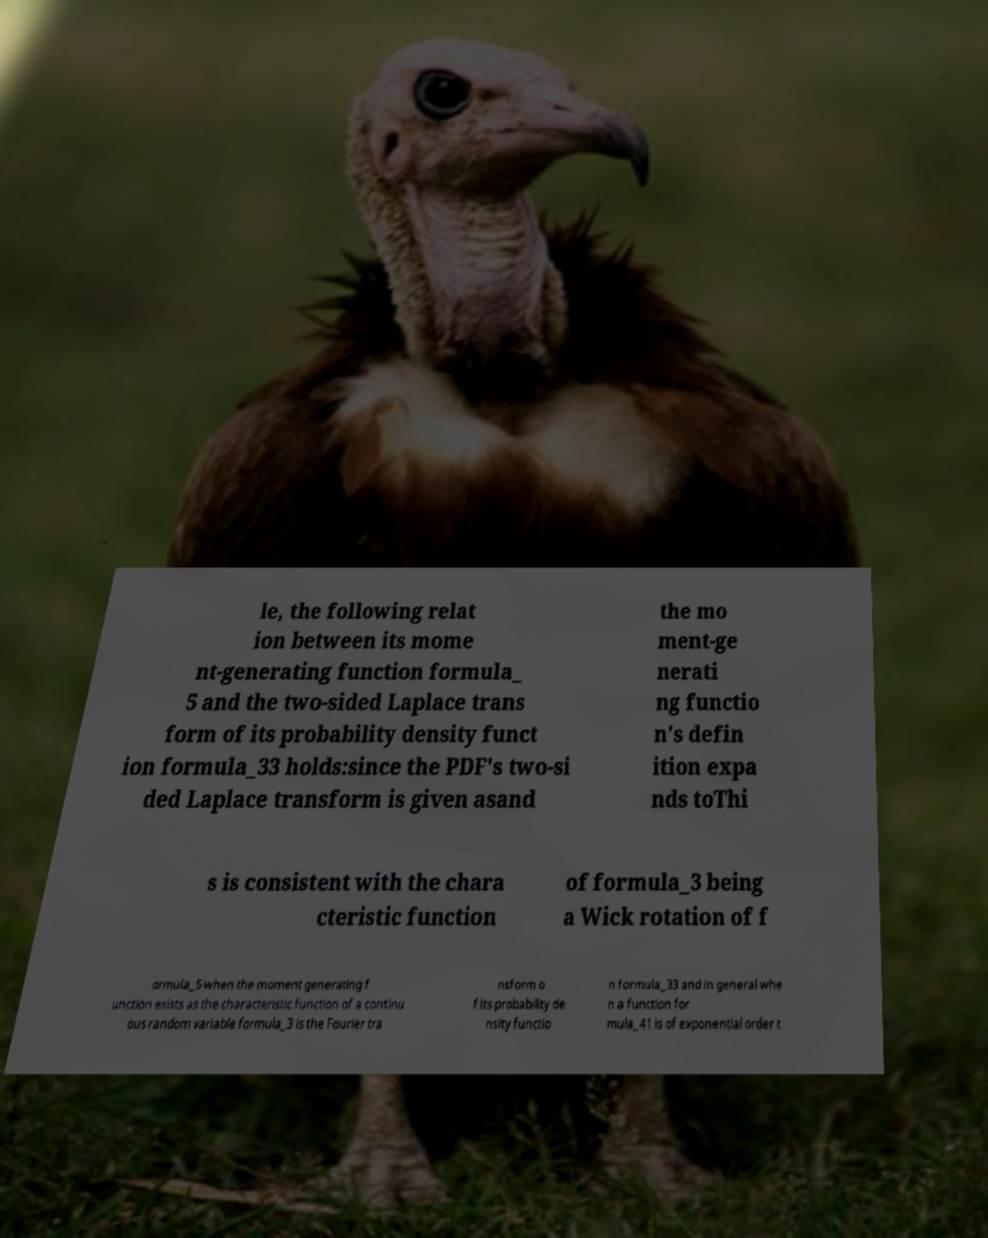I need the written content from this picture converted into text. Can you do that? le, the following relat ion between its mome nt-generating function formula_ 5 and the two-sided Laplace trans form of its probability density funct ion formula_33 holds:since the PDF's two-si ded Laplace transform is given asand the mo ment-ge nerati ng functio n's defin ition expa nds toThi s is consistent with the chara cteristic function of formula_3 being a Wick rotation of f ormula_5 when the moment generating f unction exists as the characteristic function of a continu ous random variable formula_3 is the Fourier tra nsform o f its probability de nsity functio n formula_33 and in general whe n a function for mula_41 is of exponential order t 